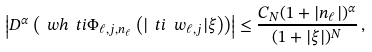Convert formula to latex. <formula><loc_0><loc_0><loc_500><loc_500>\left | D ^ { \alpha } \left ( \ w h { \ t i \Phi _ { \ell , j , n _ { \ell } } } \left ( | \ t i \ w _ { \ell , j } | \xi \right ) \right ) \right | \leq \frac { C _ { N } ( 1 + | n _ { \ell } | ) ^ { \alpha } } { ( 1 + | \xi | ) ^ { N } } \, ,</formula> 